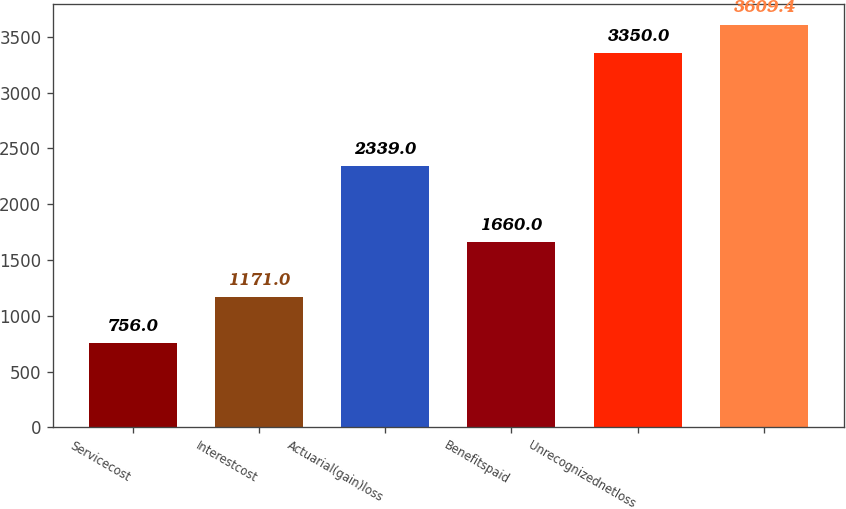Convert chart. <chart><loc_0><loc_0><loc_500><loc_500><bar_chart><fcel>Servicecost<fcel>Interestcost<fcel>Actuarial(gain)loss<fcel>Benefitspaid<fcel>Unrecognizednetloss<fcel>Unnamed: 5<nl><fcel>756<fcel>1171<fcel>2339<fcel>1660<fcel>3350<fcel>3609.4<nl></chart> 